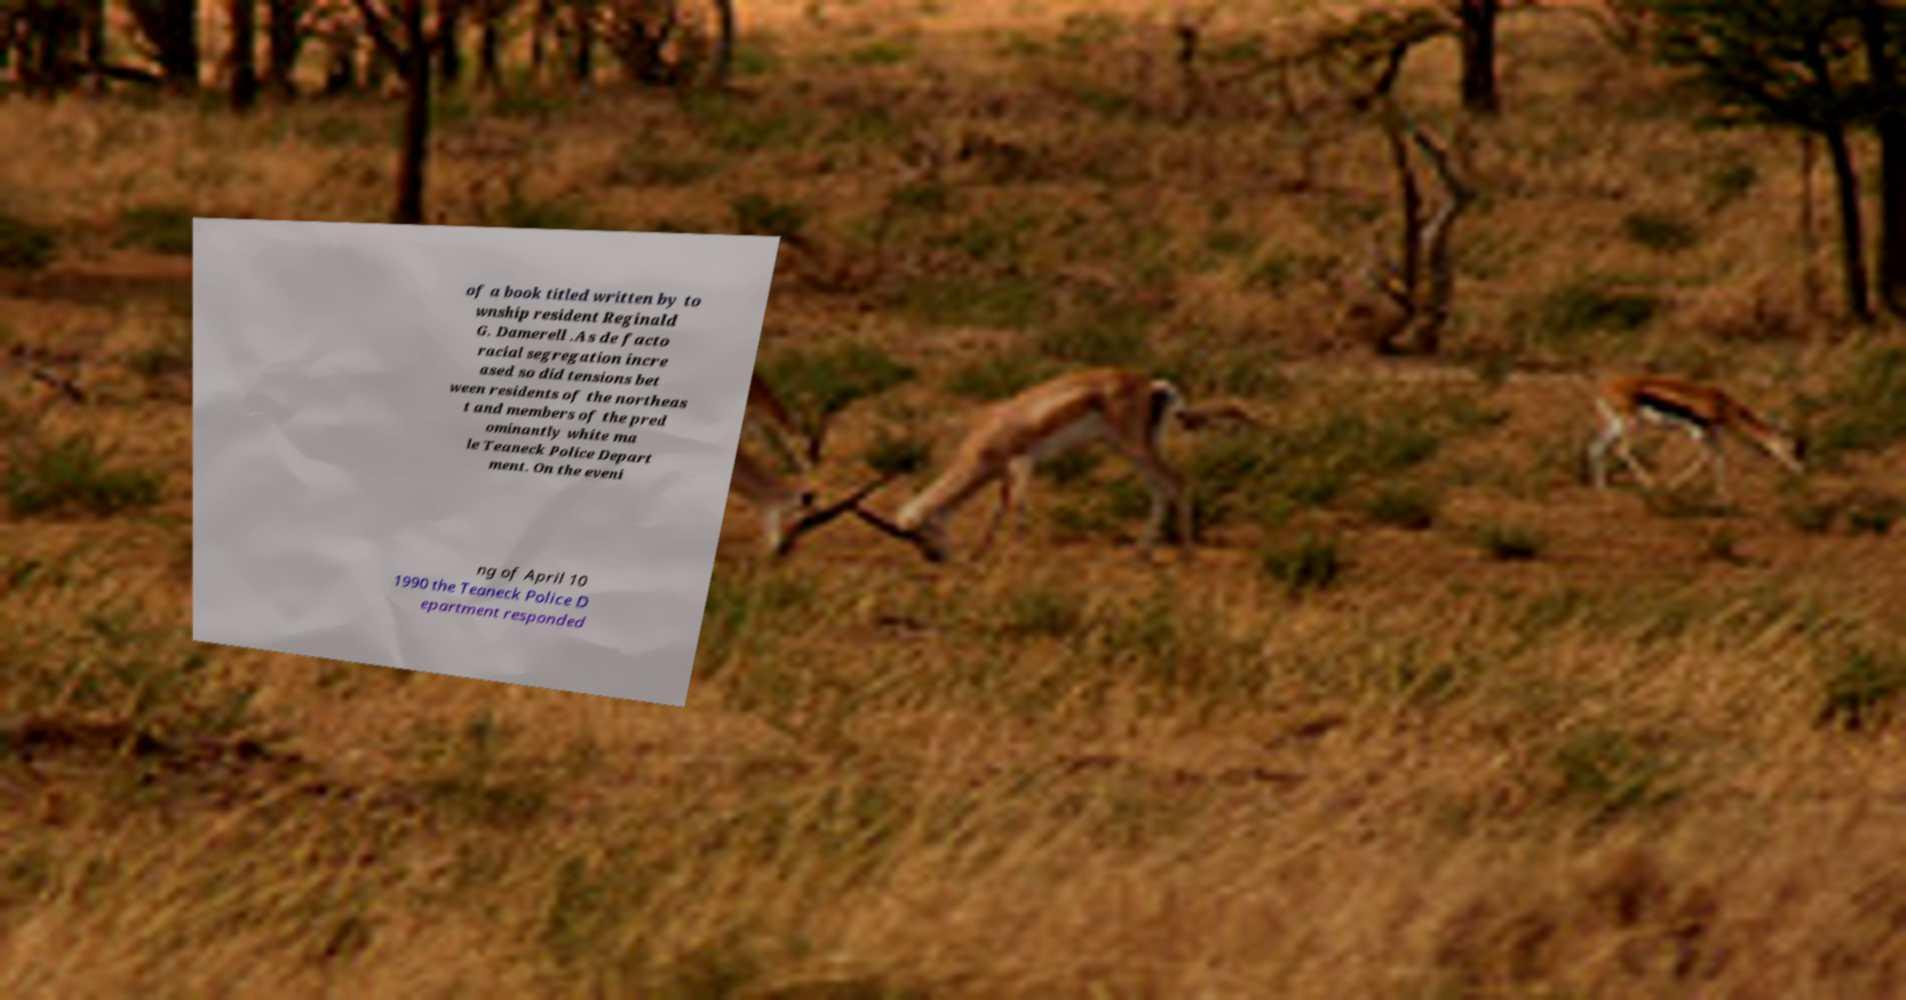For documentation purposes, I need the text within this image transcribed. Could you provide that? of a book titled written by to wnship resident Reginald G. Damerell .As de facto racial segregation incre ased so did tensions bet ween residents of the northeas t and members of the pred ominantly white ma le Teaneck Police Depart ment. On the eveni ng of April 10 1990 the Teaneck Police D epartment responded 